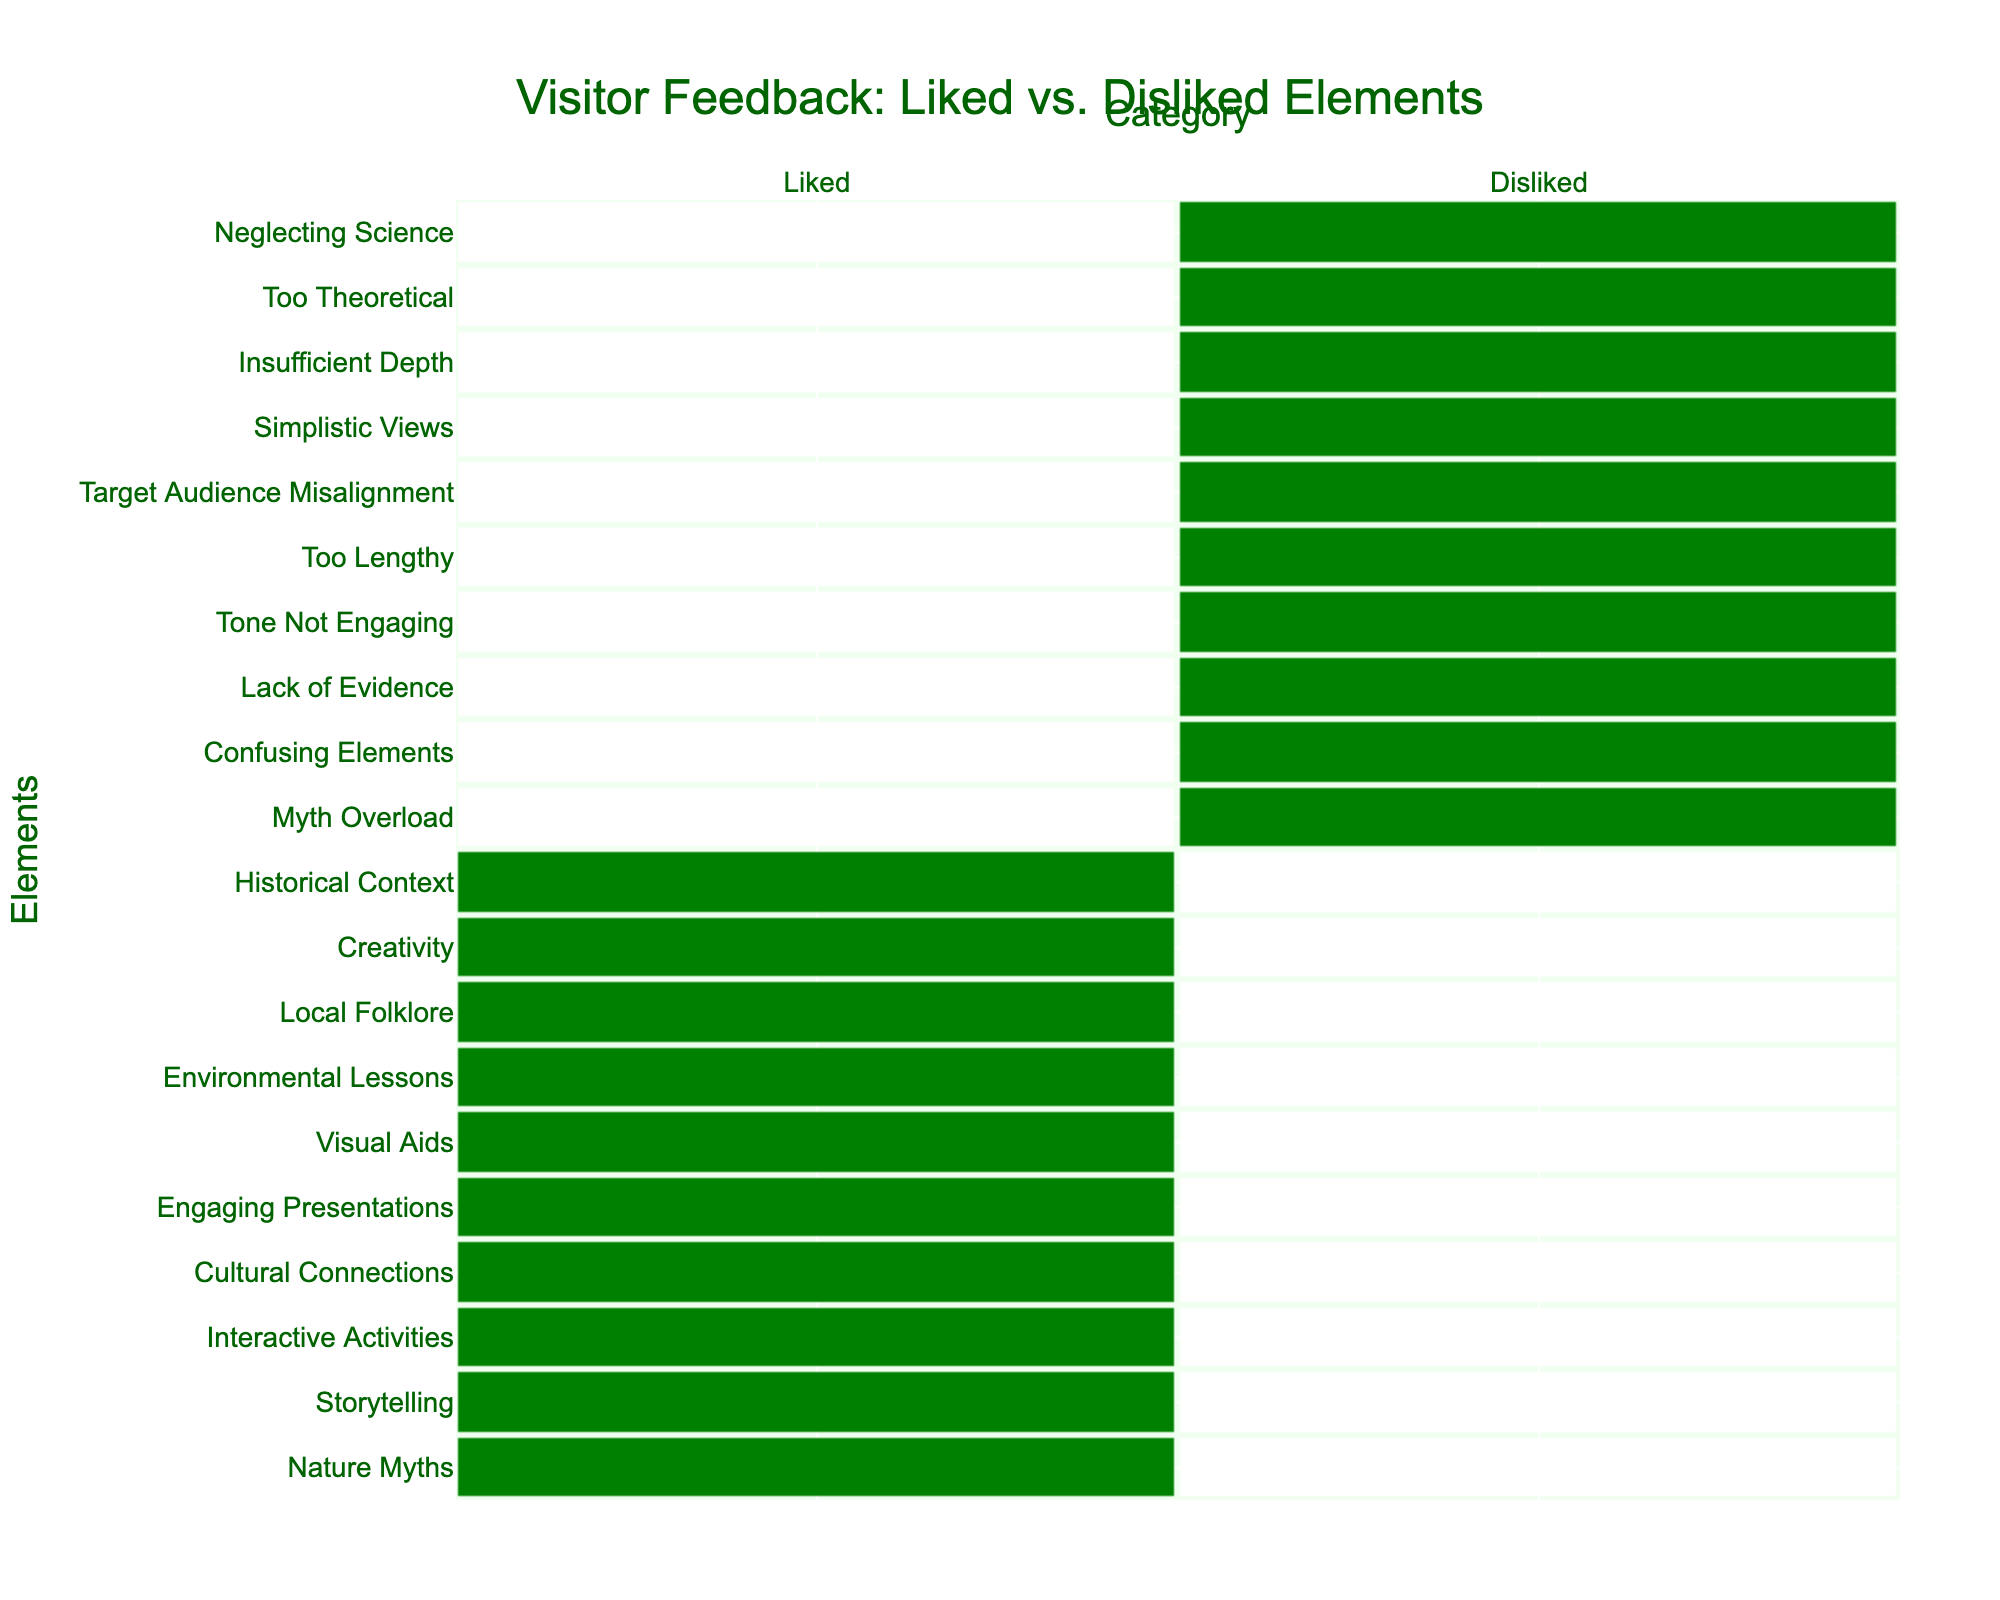What are the elements that visitors liked the most? The liked elements are listed in the left column of the table. They are Nature Myths, Storytelling, Interactive Activities, Cultural Connections, Engaging Presentations, Visual Aids, Environmental Lessons, Local Folklore, Creativity, and Historical Context.
Answer: Nature Myths, Storytelling, Interactive Activities, Cultural Connections, Engaging Presentations, Visual Aids, Environmental Lessons, Local Folklore, Creativity, Historical Context Which element was disliked due to lack of evidence? The disliked element "Lack of Evidence" corresponds to the liked element "Interactive Activities" based on the table’s structure. This can be deduced directly since "Lack of Evidence" is specifically mentioned under the Disliked category.
Answer: Interactive Activities How many elements are there in total when combining liked and disliked? The table lists 10 liked elements and 10 disliked elements. Therefore, adding them gives a total of 20 elements. This is calculated by simply summing the two individual counts: 10 + 10 = 20.
Answer: 20 Is "Creativity" listed as a disliked element? The table shows "Creativity" in the liked column and not the disliked column. Therefore, it can be confirmed that it is not listed as disliked.
Answer: No Which two disliked elements are seen as too lengthy or not engaging? By examining the disliked column, "Tone Not Engaging" and "Too Lengthy" can be identified as those elements. The explanation follows from directly reading the respective entries under the Disliked category.
Answer: Tone Not Engaging, Too Lengthy What is the relationship between "Local Folklore" and "Simplistic Views"? "Local Folklore" is categorized as liked while "Simplistic Views" is disliked. This indicates that while some visitors appreciated the folklore incorporated in the education, others found aspects of it overly simplistic, showing an appreciation for detail contrasted by preference for more complex narratives.
Answer: Positive appreciation vs. negative critique How many total negative feedback elements are considered confusing or theoretical? The table shows that "Confusing Elements" appears once (disliked) and "Too Theoretical" appears once as well, leading to a total of 2 elements that fall under this category. A simple count of those specific disliked elements leads to this conclusion: 1 (confusing) + 1 (theoretical) = 2.
Answer: 2 Which liked elements may suggest an interest in cultural aspects of nature? The liked elements "Cultural Connections" and "Local Folklore" are evident in the table as appealing to visitors' interests in cultural aspects. This can be determined by recognizing the emphasis placed on culture in their titles.
Answer: Cultural Connections, Local Folklore Are there more liked elements than disliked ones? The table provides 10 liked elements compared to 10 disliked elements. Therefore, the counts are equal, meaning there are not more liked elements than disliked.
Answer: No 